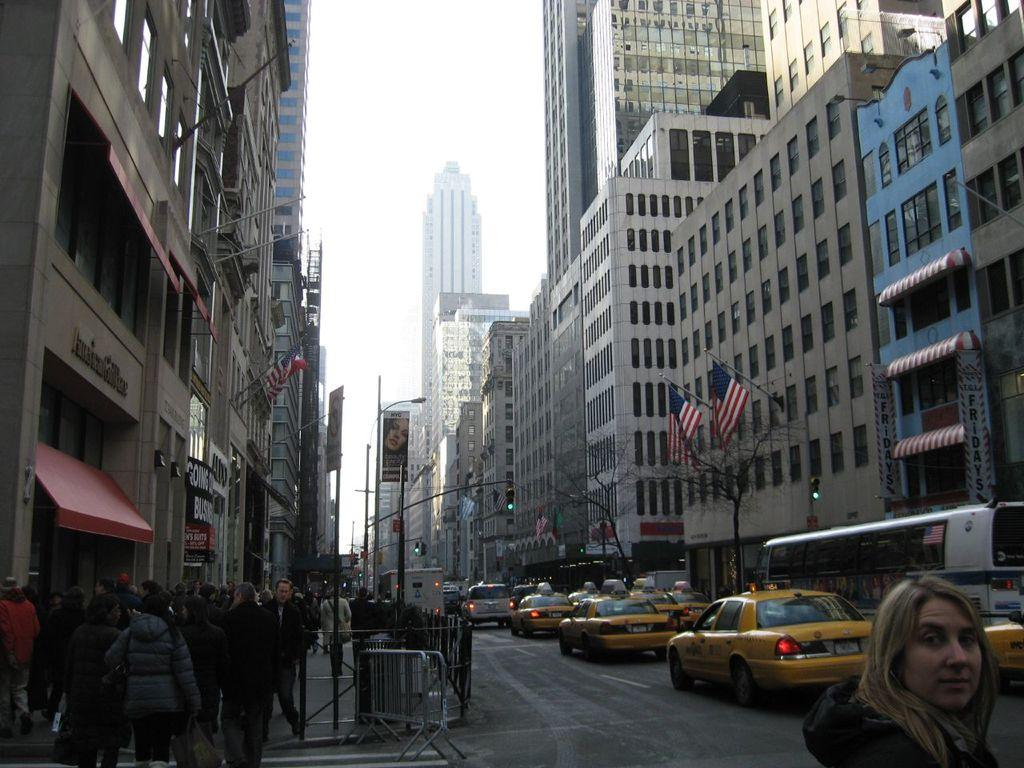<image>
Give a short and clear explanation of the subsequent image. A city street view with TGI Friday's on one side and a going out business sale on the other side. 